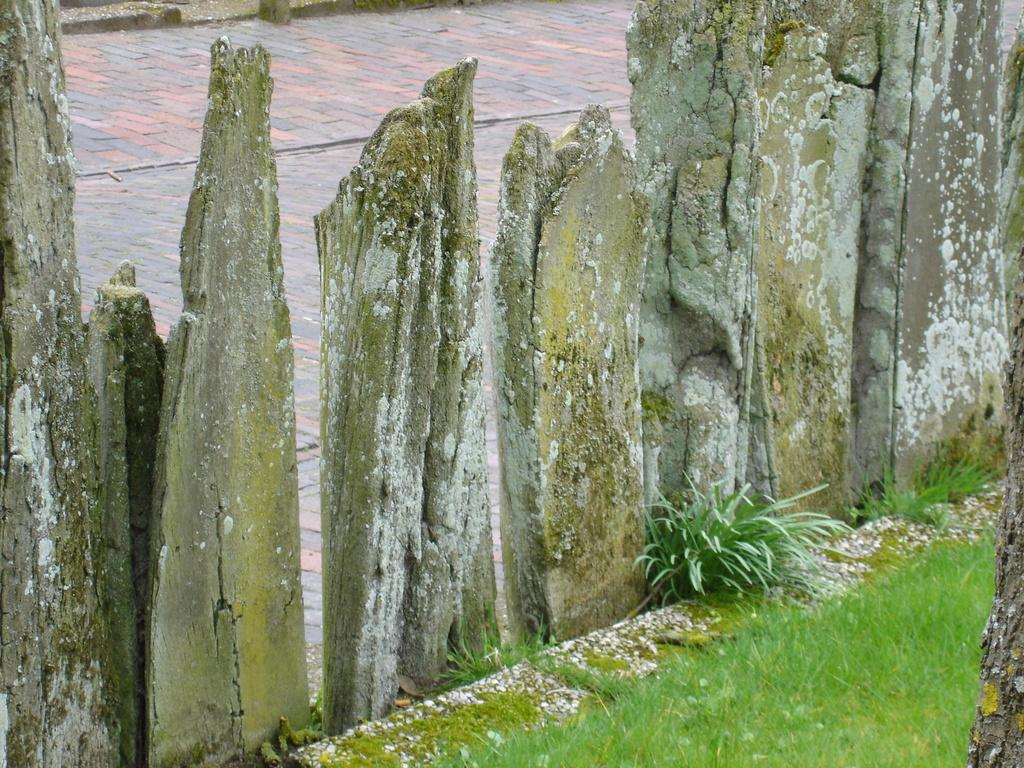What type of natural elements can be seen in the image? There are stones, grass, and plants visible in the image. What is the surface on which these elements are located? The ground is visible in the image. What type of fowl can be seen in the image? There is no fowl present in the image; it only features stones, grass, plants, and the ground. 